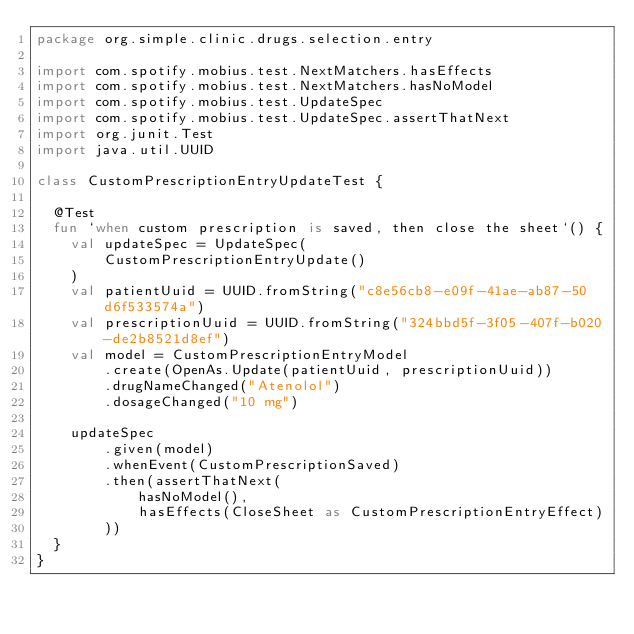Convert code to text. <code><loc_0><loc_0><loc_500><loc_500><_Kotlin_>package org.simple.clinic.drugs.selection.entry

import com.spotify.mobius.test.NextMatchers.hasEffects
import com.spotify.mobius.test.NextMatchers.hasNoModel
import com.spotify.mobius.test.UpdateSpec
import com.spotify.mobius.test.UpdateSpec.assertThatNext
import org.junit.Test
import java.util.UUID

class CustomPrescriptionEntryUpdateTest {

  @Test
  fun `when custom prescription is saved, then close the sheet`() {
    val updateSpec = UpdateSpec(
        CustomPrescriptionEntryUpdate()
    )
    val patientUuid = UUID.fromString("c8e56cb8-e09f-41ae-ab87-50d6f533574a")
    val prescriptionUuid = UUID.fromString("324bbd5f-3f05-407f-b020-de2b8521d8ef")
    val model = CustomPrescriptionEntryModel
        .create(OpenAs.Update(patientUuid, prescriptionUuid))
        .drugNameChanged("Atenolol")
        .dosageChanged("10 mg")

    updateSpec
        .given(model)
        .whenEvent(CustomPrescriptionSaved)
        .then(assertThatNext(
            hasNoModel(),
            hasEffects(CloseSheet as CustomPrescriptionEntryEffect)
        ))
  }
}
</code> 